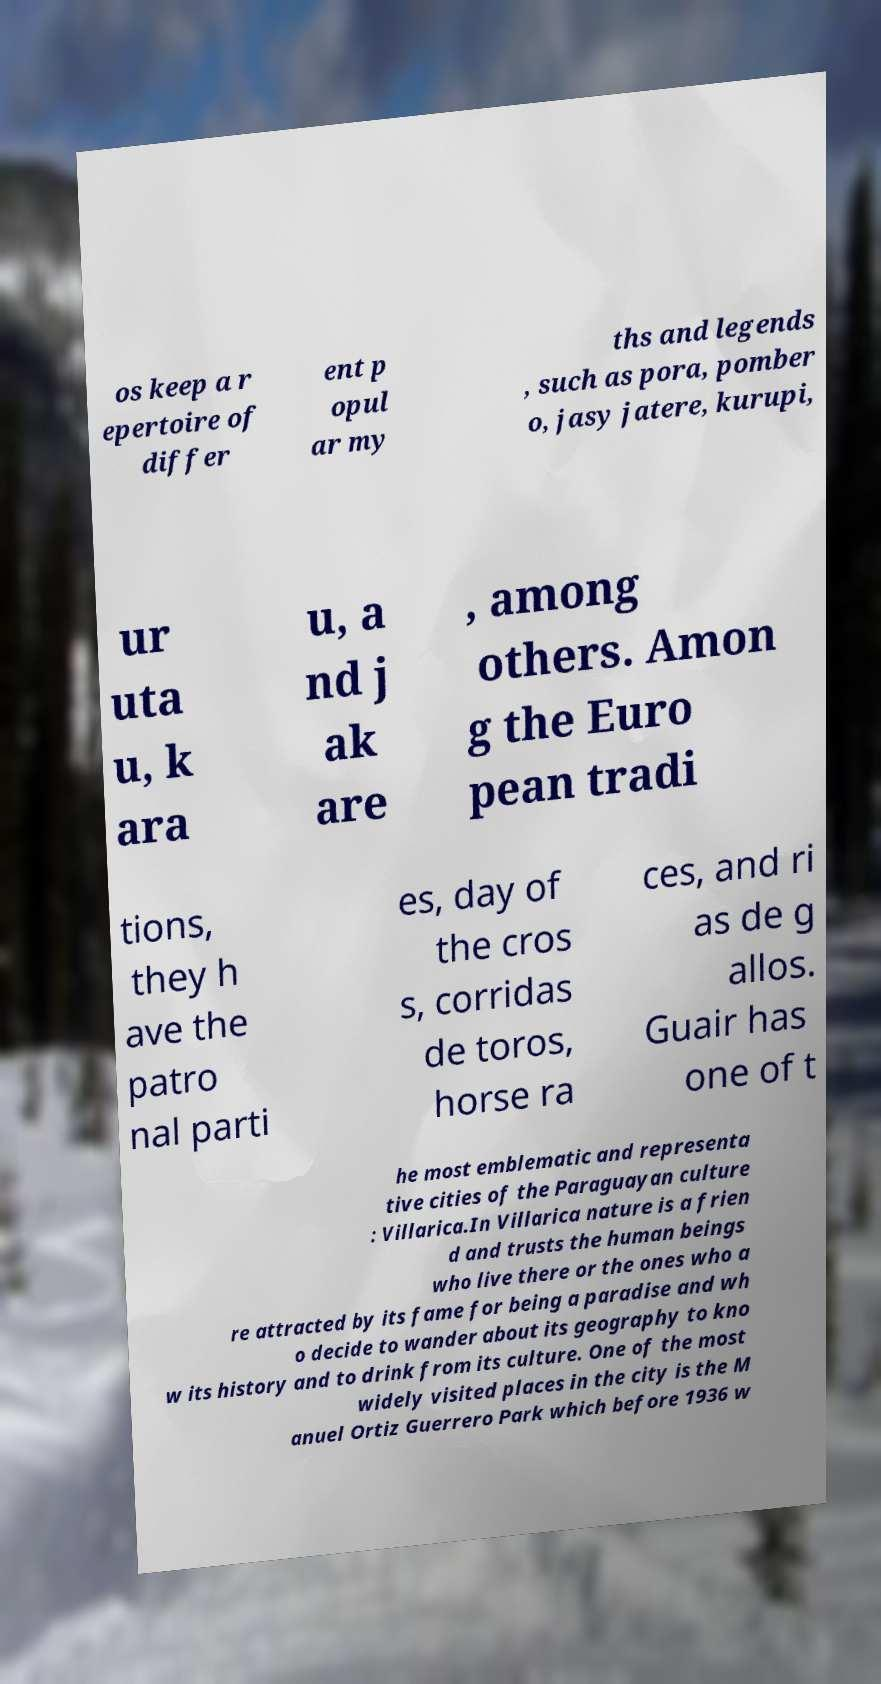Please read and relay the text visible in this image. What does it say? os keep a r epertoire of differ ent p opul ar my ths and legends , such as pora, pomber o, jasy jatere, kurupi, ur uta u, k ara u, a nd j ak are , among others. Amon g the Euro pean tradi tions, they h ave the patro nal parti es, day of the cros s, corridas de toros, horse ra ces, and ri as de g allos. Guair has one of t he most emblematic and representa tive cities of the Paraguayan culture : Villarica.In Villarica nature is a frien d and trusts the human beings who live there or the ones who a re attracted by its fame for being a paradise and wh o decide to wander about its geography to kno w its history and to drink from its culture. One of the most widely visited places in the city is the M anuel Ortiz Guerrero Park which before 1936 w 